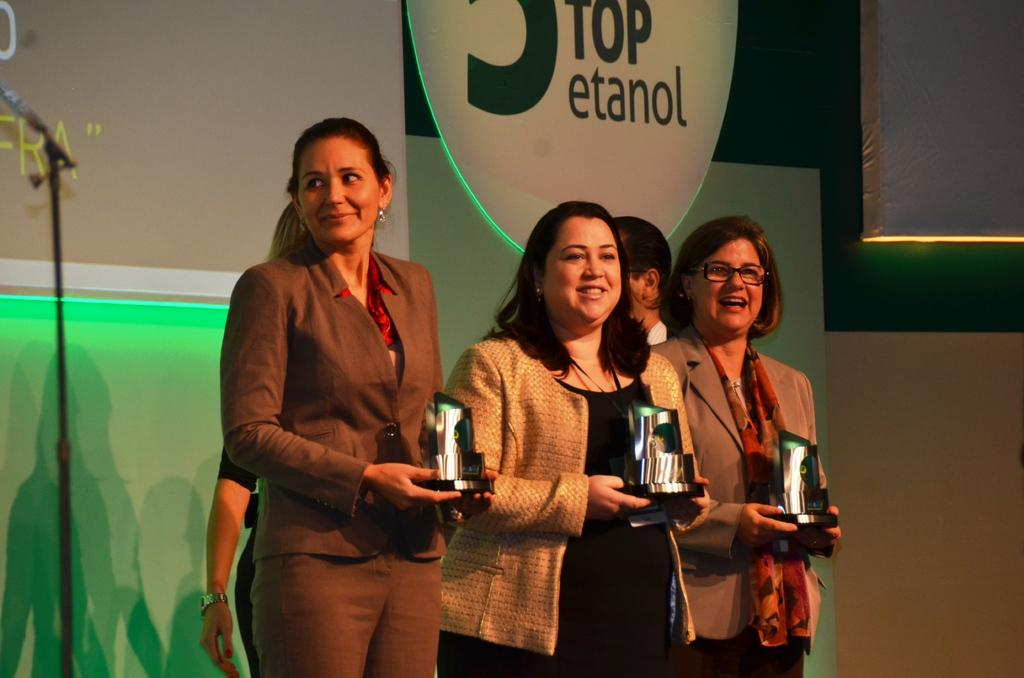What is the main subject of the image? The main subject of the image is the women standing in the middle. What are the women holding in their hands? The women are holding something in their hands, but the specific object is not mentioned in the facts. Are there any other people in the image besides the women? Yes, there are two persons standing behind the women. What can be seen in the background of the image? There is a wall visible in the background. Reasoning: Let's think step by step by step in order to produce the conversation. We start by identifying the main subject of the image, which is the women standing in the middle. Then, we describe what they are holding in their hands, even though the specific object is not mentioned in the facts. Next, we acknowledge the presence of the two persons standing behind the women. Finally, we describe the background of the image, which includes a wall. Absurd Question/Answer: What type of jeans are the women wearing in the image? There is no mention of jeans in the image, so it is not possible to determine what type of jeans the women might be wearing. How does the breath of the women affect the image? There is no mention of breath in the image, so it is not possible to determine how the breath of the women might affect the image. 